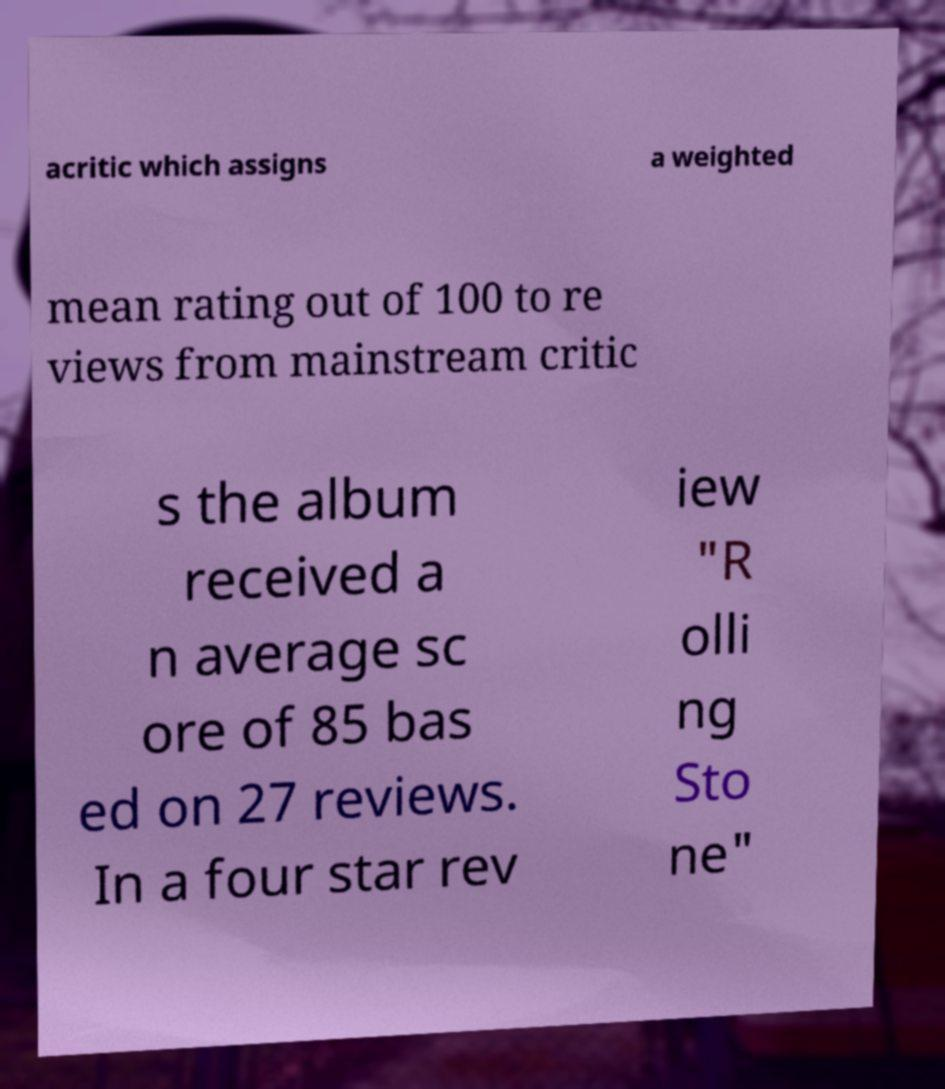I need the written content from this picture converted into text. Can you do that? acritic which assigns a weighted mean rating out of 100 to re views from mainstream critic s the album received a n average sc ore of 85 bas ed on 27 reviews. In a four star rev iew "R olli ng Sto ne" 